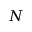<formula> <loc_0><loc_0><loc_500><loc_500>N</formula> 